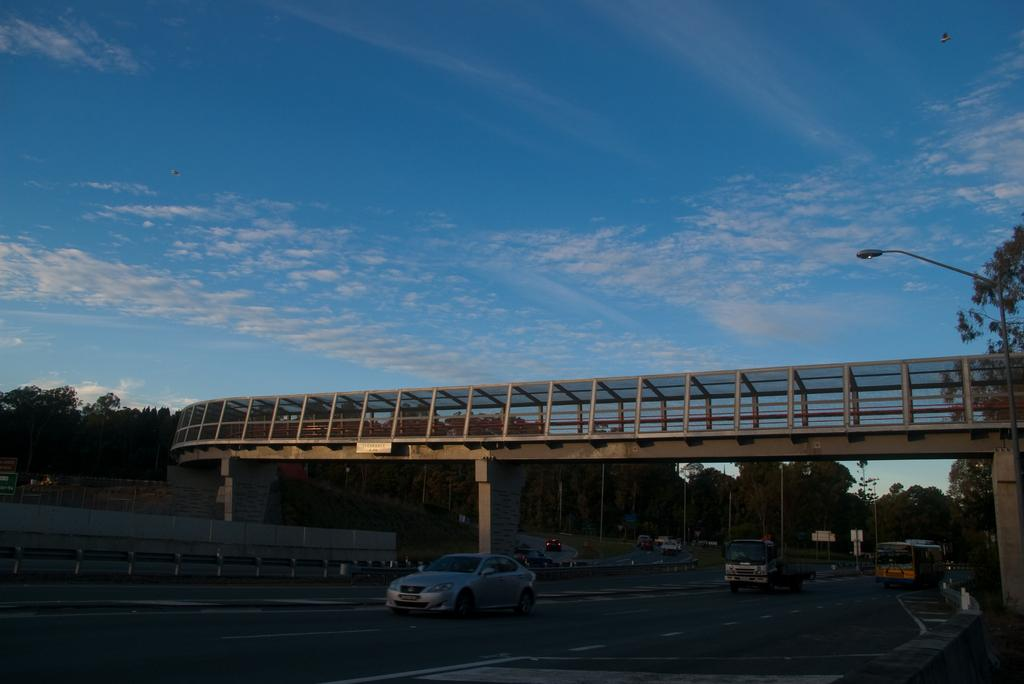What can be seen on the road in the image? There is a group of vehicles on the road in the image. What type of barrier is present in the image? There is a fence in the image. What type of structure is visible in the image? There is a bridge in the image. What type of vertical structure is present in the image? There is a street pole in the image. How many poles are visible in the image? There are poles in the image. What type of vegetation can be seen in the image? There is a group of trees in the image. What is visible in the background of the image? The sky is visible in the image. What is the condition of the sky in the image? The sky appears to be cloudy in the image. What type of doctor can be seen treating the vehicles in the image? There is no doctor present in the image, and vehicles do not require medical treatment. What type of voice can be heard coming from the trees in the image? There is no voice present in the image, as trees do not have the ability to produce sound. 